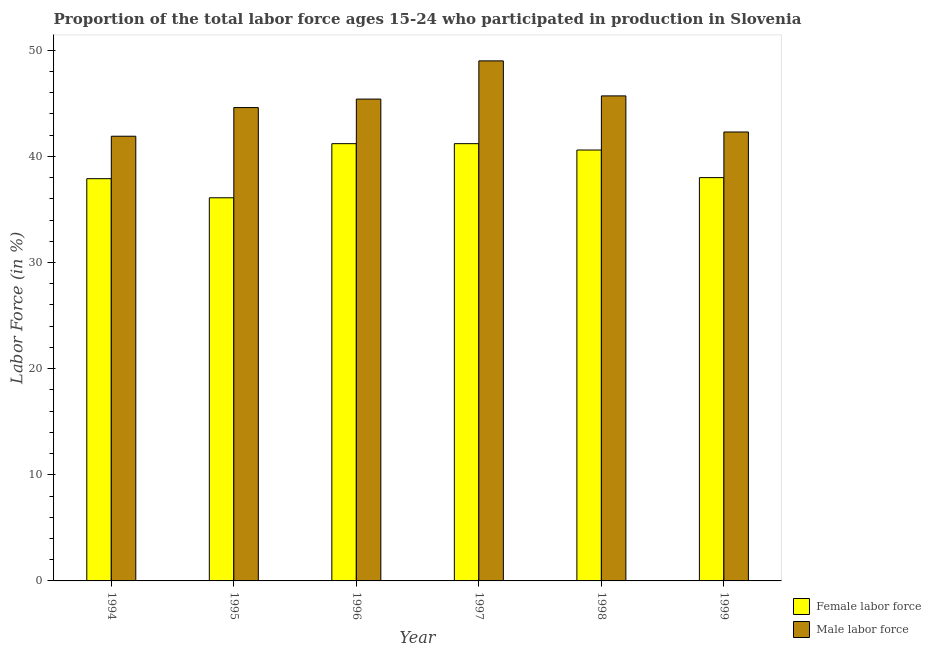How many different coloured bars are there?
Make the answer very short. 2. How many groups of bars are there?
Provide a succinct answer. 6. Are the number of bars per tick equal to the number of legend labels?
Offer a very short reply. Yes. Are the number of bars on each tick of the X-axis equal?
Your answer should be very brief. Yes. How many bars are there on the 4th tick from the left?
Offer a very short reply. 2. What is the percentage of male labour force in 1995?
Make the answer very short. 44.6. Across all years, what is the maximum percentage of female labor force?
Your answer should be very brief. 41.2. Across all years, what is the minimum percentage of male labour force?
Your answer should be compact. 41.9. In which year was the percentage of female labor force maximum?
Offer a terse response. 1996. In which year was the percentage of female labor force minimum?
Offer a terse response. 1995. What is the total percentage of female labor force in the graph?
Provide a short and direct response. 235. What is the difference between the percentage of male labour force in 1995 and that in 1996?
Keep it short and to the point. -0.8. What is the difference between the percentage of female labor force in 1994 and the percentage of male labour force in 1995?
Your answer should be compact. 1.8. What is the average percentage of female labor force per year?
Give a very brief answer. 39.17. In how many years, is the percentage of female labor force greater than 28 %?
Offer a terse response. 6. What is the ratio of the percentage of male labour force in 1994 to that in 1996?
Your answer should be compact. 0.92. What is the difference between the highest and the second highest percentage of male labour force?
Provide a short and direct response. 3.3. What is the difference between the highest and the lowest percentage of female labor force?
Your answer should be compact. 5.1. What does the 1st bar from the left in 1999 represents?
Your response must be concise. Female labor force. What does the 2nd bar from the right in 1998 represents?
Offer a very short reply. Female labor force. How many bars are there?
Provide a short and direct response. 12. Are all the bars in the graph horizontal?
Provide a succinct answer. No. How many years are there in the graph?
Your response must be concise. 6. What is the difference between two consecutive major ticks on the Y-axis?
Give a very brief answer. 10. Are the values on the major ticks of Y-axis written in scientific E-notation?
Your answer should be compact. No. Does the graph contain grids?
Make the answer very short. No. Where does the legend appear in the graph?
Provide a succinct answer. Bottom right. How many legend labels are there?
Ensure brevity in your answer.  2. How are the legend labels stacked?
Your response must be concise. Vertical. What is the title of the graph?
Offer a terse response. Proportion of the total labor force ages 15-24 who participated in production in Slovenia. Does "Investment" appear as one of the legend labels in the graph?
Provide a short and direct response. No. What is the label or title of the Y-axis?
Make the answer very short. Labor Force (in %). What is the Labor Force (in %) of Female labor force in 1994?
Ensure brevity in your answer.  37.9. What is the Labor Force (in %) in Male labor force in 1994?
Your answer should be very brief. 41.9. What is the Labor Force (in %) of Female labor force in 1995?
Provide a short and direct response. 36.1. What is the Labor Force (in %) in Male labor force in 1995?
Give a very brief answer. 44.6. What is the Labor Force (in %) in Female labor force in 1996?
Your response must be concise. 41.2. What is the Labor Force (in %) of Male labor force in 1996?
Offer a terse response. 45.4. What is the Labor Force (in %) of Female labor force in 1997?
Make the answer very short. 41.2. What is the Labor Force (in %) of Male labor force in 1997?
Give a very brief answer. 49. What is the Labor Force (in %) of Female labor force in 1998?
Make the answer very short. 40.6. What is the Labor Force (in %) in Male labor force in 1998?
Ensure brevity in your answer.  45.7. What is the Labor Force (in %) of Male labor force in 1999?
Offer a terse response. 42.3. Across all years, what is the maximum Labor Force (in %) of Female labor force?
Make the answer very short. 41.2. Across all years, what is the minimum Labor Force (in %) of Female labor force?
Your answer should be very brief. 36.1. Across all years, what is the minimum Labor Force (in %) in Male labor force?
Your answer should be compact. 41.9. What is the total Labor Force (in %) in Female labor force in the graph?
Make the answer very short. 235. What is the total Labor Force (in %) in Male labor force in the graph?
Ensure brevity in your answer.  268.9. What is the difference between the Labor Force (in %) of Male labor force in 1994 and that in 1996?
Ensure brevity in your answer.  -3.5. What is the difference between the Labor Force (in %) in Male labor force in 1994 and that in 1997?
Your response must be concise. -7.1. What is the difference between the Labor Force (in %) of Female labor force in 1994 and that in 1998?
Ensure brevity in your answer.  -2.7. What is the difference between the Labor Force (in %) of Female labor force in 1995 and that in 1997?
Provide a short and direct response. -5.1. What is the difference between the Labor Force (in %) in Male labor force in 1995 and that in 1997?
Your response must be concise. -4.4. What is the difference between the Labor Force (in %) of Male labor force in 1995 and that in 1998?
Give a very brief answer. -1.1. What is the difference between the Labor Force (in %) of Female labor force in 1995 and that in 1999?
Offer a terse response. -1.9. What is the difference between the Labor Force (in %) in Male labor force in 1995 and that in 1999?
Offer a very short reply. 2.3. What is the difference between the Labor Force (in %) in Female labor force in 1996 and that in 1997?
Offer a terse response. 0. What is the difference between the Labor Force (in %) in Female labor force in 1997 and that in 1998?
Ensure brevity in your answer.  0.6. What is the difference between the Labor Force (in %) of Female labor force in 1997 and that in 1999?
Ensure brevity in your answer.  3.2. What is the difference between the Labor Force (in %) in Male labor force in 1997 and that in 1999?
Keep it short and to the point. 6.7. What is the difference between the Labor Force (in %) in Female labor force in 1998 and that in 1999?
Your answer should be compact. 2.6. What is the difference between the Labor Force (in %) of Male labor force in 1998 and that in 1999?
Give a very brief answer. 3.4. What is the difference between the Labor Force (in %) of Female labor force in 1994 and the Labor Force (in %) of Male labor force in 1995?
Provide a short and direct response. -6.7. What is the difference between the Labor Force (in %) of Female labor force in 1995 and the Labor Force (in %) of Male labor force in 1996?
Ensure brevity in your answer.  -9.3. What is the difference between the Labor Force (in %) of Female labor force in 1995 and the Labor Force (in %) of Male labor force in 1998?
Offer a very short reply. -9.6. What is the difference between the Labor Force (in %) in Female labor force in 1995 and the Labor Force (in %) in Male labor force in 1999?
Provide a succinct answer. -6.2. What is the difference between the Labor Force (in %) in Female labor force in 1996 and the Labor Force (in %) in Male labor force in 1997?
Give a very brief answer. -7.8. What is the difference between the Labor Force (in %) in Female labor force in 1997 and the Labor Force (in %) in Male labor force in 1998?
Keep it short and to the point. -4.5. What is the difference between the Labor Force (in %) in Female labor force in 1997 and the Labor Force (in %) in Male labor force in 1999?
Provide a succinct answer. -1.1. What is the average Labor Force (in %) in Female labor force per year?
Offer a terse response. 39.17. What is the average Labor Force (in %) in Male labor force per year?
Make the answer very short. 44.82. In the year 1994, what is the difference between the Labor Force (in %) in Female labor force and Labor Force (in %) in Male labor force?
Offer a terse response. -4. In the year 1996, what is the difference between the Labor Force (in %) of Female labor force and Labor Force (in %) of Male labor force?
Ensure brevity in your answer.  -4.2. In the year 1999, what is the difference between the Labor Force (in %) of Female labor force and Labor Force (in %) of Male labor force?
Give a very brief answer. -4.3. What is the ratio of the Labor Force (in %) of Female labor force in 1994 to that in 1995?
Give a very brief answer. 1.05. What is the ratio of the Labor Force (in %) in Male labor force in 1994 to that in 1995?
Give a very brief answer. 0.94. What is the ratio of the Labor Force (in %) of Female labor force in 1994 to that in 1996?
Provide a succinct answer. 0.92. What is the ratio of the Labor Force (in %) of Male labor force in 1994 to that in 1996?
Provide a succinct answer. 0.92. What is the ratio of the Labor Force (in %) of Female labor force in 1994 to that in 1997?
Your answer should be very brief. 0.92. What is the ratio of the Labor Force (in %) in Male labor force in 1994 to that in 1997?
Offer a terse response. 0.86. What is the ratio of the Labor Force (in %) in Female labor force in 1994 to that in 1998?
Give a very brief answer. 0.93. What is the ratio of the Labor Force (in %) of Male labor force in 1994 to that in 1998?
Your answer should be very brief. 0.92. What is the ratio of the Labor Force (in %) in Female labor force in 1995 to that in 1996?
Your answer should be very brief. 0.88. What is the ratio of the Labor Force (in %) of Male labor force in 1995 to that in 1996?
Keep it short and to the point. 0.98. What is the ratio of the Labor Force (in %) of Female labor force in 1995 to that in 1997?
Offer a very short reply. 0.88. What is the ratio of the Labor Force (in %) in Male labor force in 1995 to that in 1997?
Your answer should be compact. 0.91. What is the ratio of the Labor Force (in %) of Female labor force in 1995 to that in 1998?
Keep it short and to the point. 0.89. What is the ratio of the Labor Force (in %) in Male labor force in 1995 to that in 1998?
Ensure brevity in your answer.  0.98. What is the ratio of the Labor Force (in %) in Male labor force in 1995 to that in 1999?
Your answer should be compact. 1.05. What is the ratio of the Labor Force (in %) in Female labor force in 1996 to that in 1997?
Provide a succinct answer. 1. What is the ratio of the Labor Force (in %) of Male labor force in 1996 to that in 1997?
Your response must be concise. 0.93. What is the ratio of the Labor Force (in %) of Female labor force in 1996 to that in 1998?
Offer a terse response. 1.01. What is the ratio of the Labor Force (in %) in Male labor force in 1996 to that in 1998?
Your response must be concise. 0.99. What is the ratio of the Labor Force (in %) of Female labor force in 1996 to that in 1999?
Offer a very short reply. 1.08. What is the ratio of the Labor Force (in %) in Male labor force in 1996 to that in 1999?
Offer a very short reply. 1.07. What is the ratio of the Labor Force (in %) of Female labor force in 1997 to that in 1998?
Offer a very short reply. 1.01. What is the ratio of the Labor Force (in %) of Male labor force in 1997 to that in 1998?
Make the answer very short. 1.07. What is the ratio of the Labor Force (in %) of Female labor force in 1997 to that in 1999?
Make the answer very short. 1.08. What is the ratio of the Labor Force (in %) of Male labor force in 1997 to that in 1999?
Your answer should be compact. 1.16. What is the ratio of the Labor Force (in %) of Female labor force in 1998 to that in 1999?
Provide a succinct answer. 1.07. What is the ratio of the Labor Force (in %) of Male labor force in 1998 to that in 1999?
Offer a very short reply. 1.08. What is the difference between the highest and the second highest Labor Force (in %) of Female labor force?
Offer a terse response. 0. 